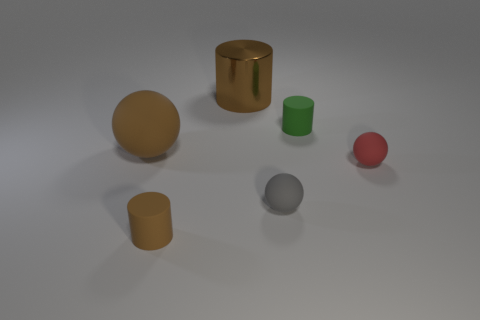Add 4 big metal objects. How many objects exist? 10 Subtract all large yellow metallic cylinders. Subtract all tiny red matte things. How many objects are left? 5 Add 6 gray objects. How many gray objects are left? 7 Add 1 rubber balls. How many rubber balls exist? 4 Subtract 0 cyan blocks. How many objects are left? 6 